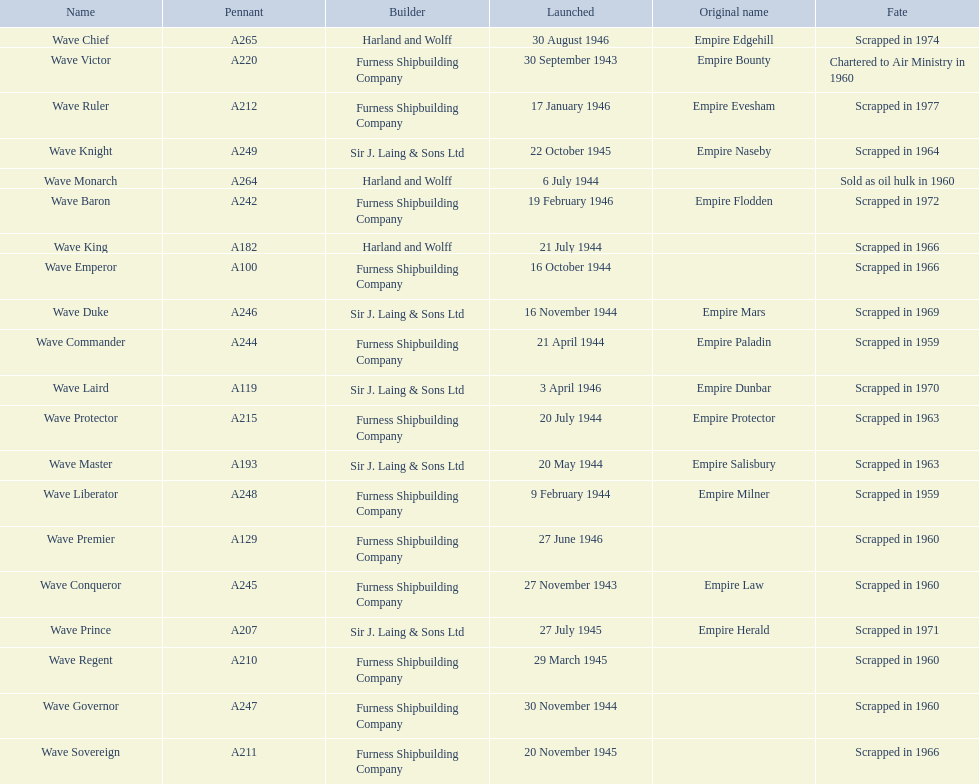What date was the first ship launched? 30 September 1943. 